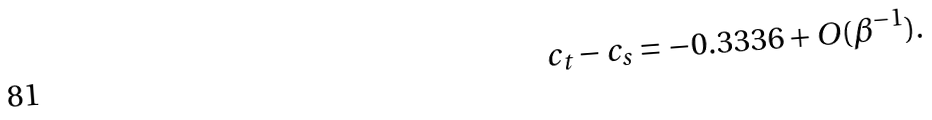Convert formula to latex. <formula><loc_0><loc_0><loc_500><loc_500>c _ { t } - c _ { s } = - 0 . 3 3 3 6 + O ( \beta ^ { - 1 } ) .</formula> 